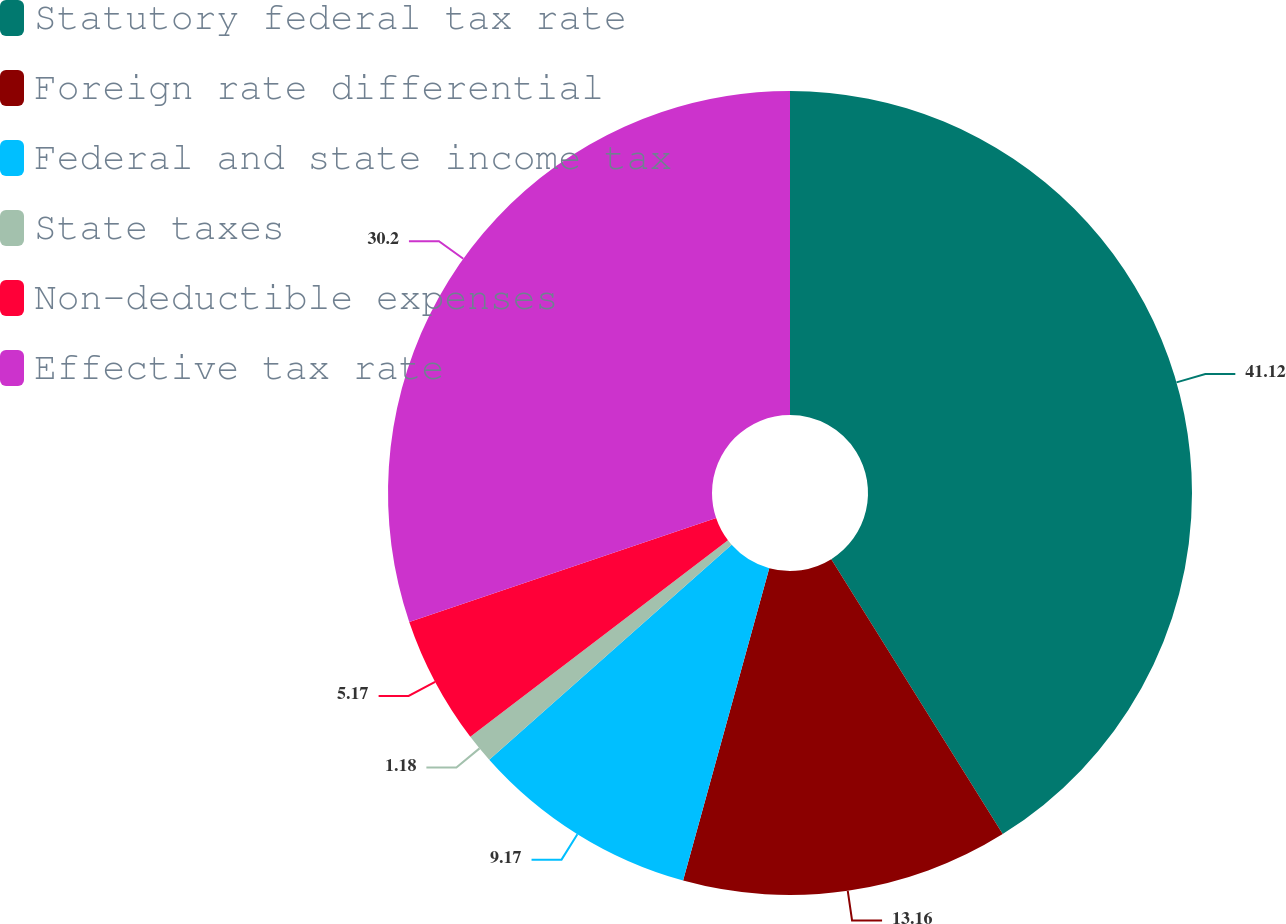Convert chart to OTSL. <chart><loc_0><loc_0><loc_500><loc_500><pie_chart><fcel>Statutory federal tax rate<fcel>Foreign rate differential<fcel>Federal and state income tax<fcel>State taxes<fcel>Non-deductible expenses<fcel>Effective tax rate<nl><fcel>41.13%<fcel>13.16%<fcel>9.17%<fcel>1.18%<fcel>5.17%<fcel>30.2%<nl></chart> 